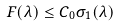<formula> <loc_0><loc_0><loc_500><loc_500>F ( \lambda ) \leq C _ { 0 } \sigma _ { 1 } ( \lambda )</formula> 